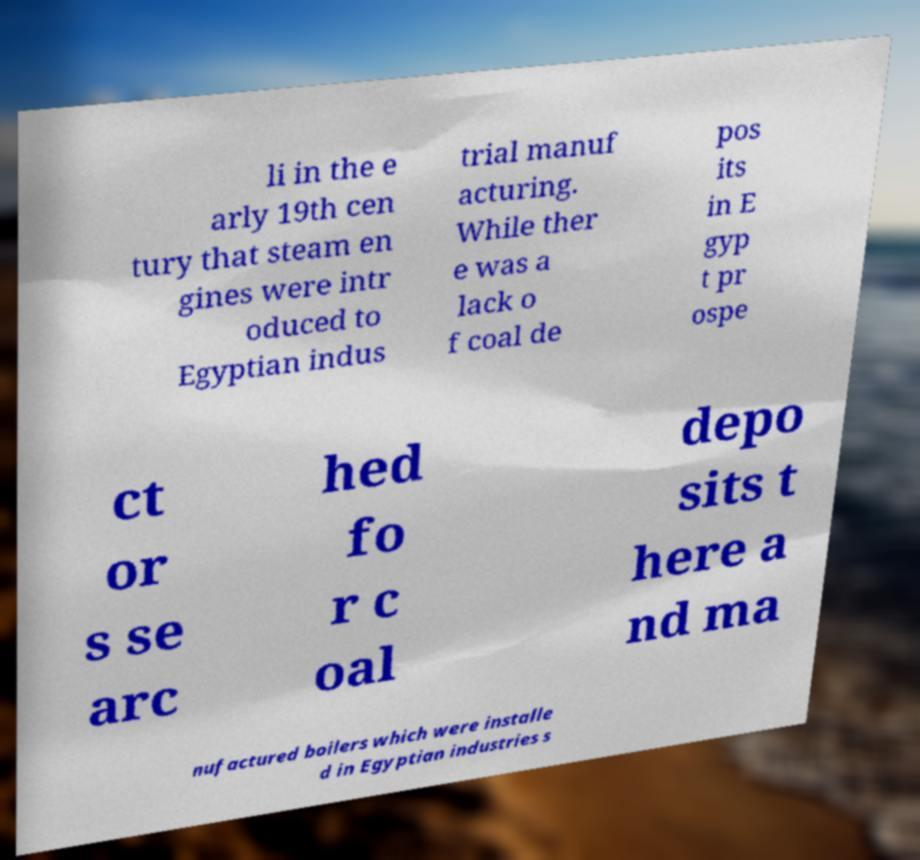Could you extract and type out the text from this image? li in the e arly 19th cen tury that steam en gines were intr oduced to Egyptian indus trial manuf acturing. While ther e was a lack o f coal de pos its in E gyp t pr ospe ct or s se arc hed fo r c oal depo sits t here a nd ma nufactured boilers which were installe d in Egyptian industries s 